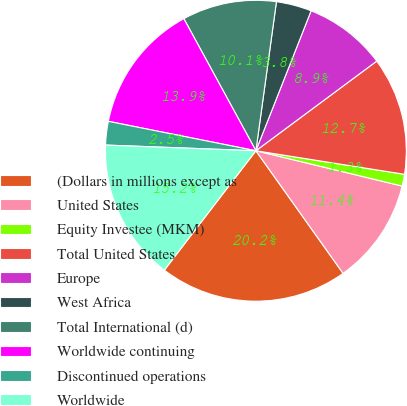Convert chart. <chart><loc_0><loc_0><loc_500><loc_500><pie_chart><fcel>(Dollars in millions except as<fcel>United States<fcel>Equity Investee (MKM)<fcel>Total United States<fcel>Europe<fcel>West Africa<fcel>Total International (d)<fcel>Worldwide continuing<fcel>Discontinued operations<fcel>Worldwide<nl><fcel>20.25%<fcel>11.39%<fcel>1.27%<fcel>12.66%<fcel>8.86%<fcel>3.8%<fcel>10.13%<fcel>13.92%<fcel>2.53%<fcel>15.19%<nl></chart> 